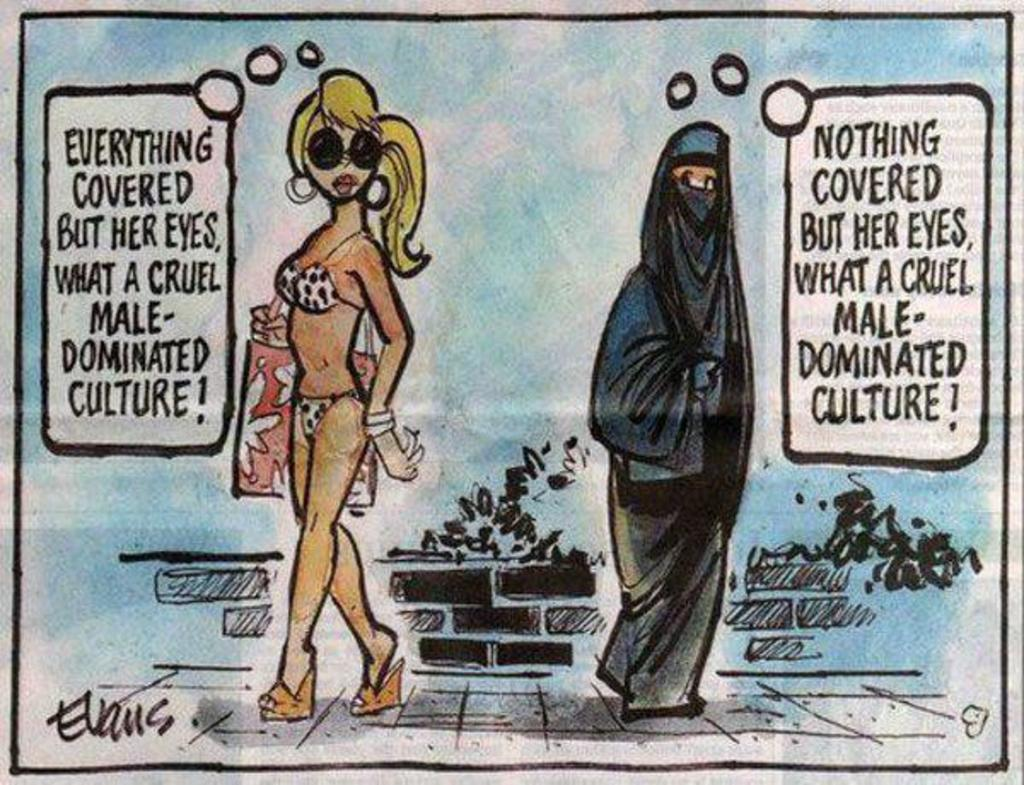What is the main subject of the image? The main subject of the image is a painting. What is the painting depicting? The painting depicts two women. What are the women doing in the painting? The women are standing on the floor. Can you describe any objects the women are holding in the painting? One of the women is carrying a bag in her hand. How many tongues can be seen in the painting? There are no tongues visible in the painting; it depicts two women standing on the floor and one of them carrying a bag. 